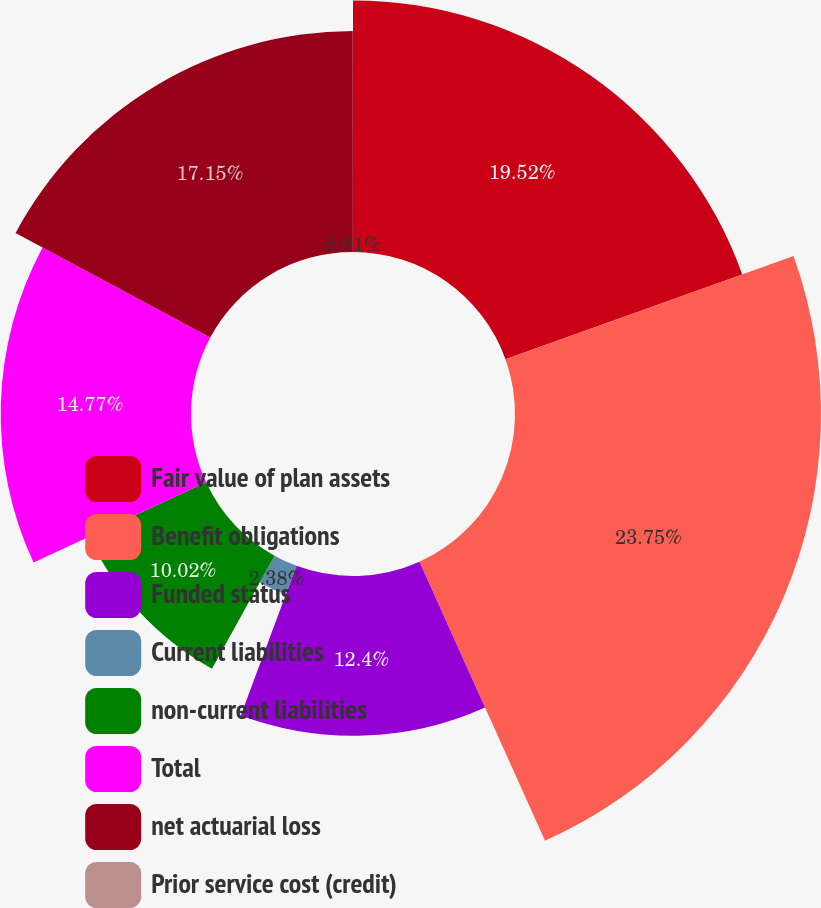<chart> <loc_0><loc_0><loc_500><loc_500><pie_chart><fcel>Fair value of plan assets<fcel>Benefit obligations<fcel>Funded status<fcel>Current liabilities<fcel>non-current liabilities<fcel>Total<fcel>net actuarial loss<fcel>Prior service cost (credit)<nl><fcel>19.52%<fcel>23.75%<fcel>12.4%<fcel>2.38%<fcel>10.02%<fcel>14.77%<fcel>17.15%<fcel>0.01%<nl></chart> 